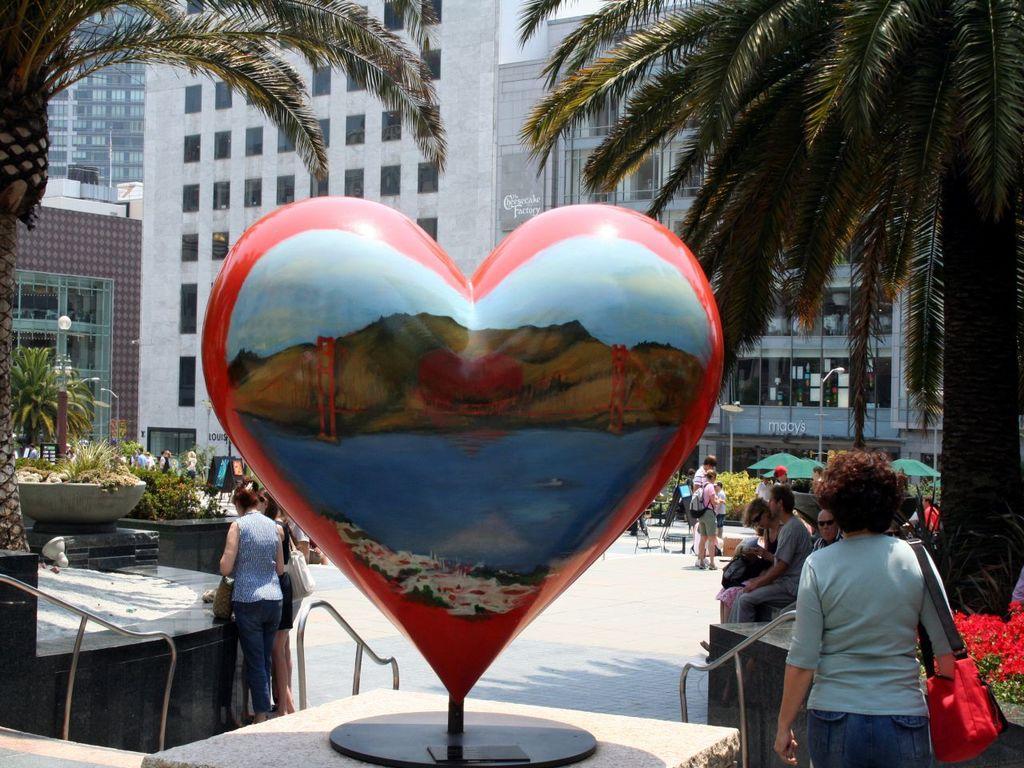Describe this image in one or two sentences. In this image we can see a love symbol object on a stand on the platform. In the background we can see few persons are sitting on a platform and few persons are standing and among them few persons are carrying bags on the shoulders and we can see plants, trees, light poles, windows, glass doors, umbrellas, plants with flowers, chairs and other objects. 